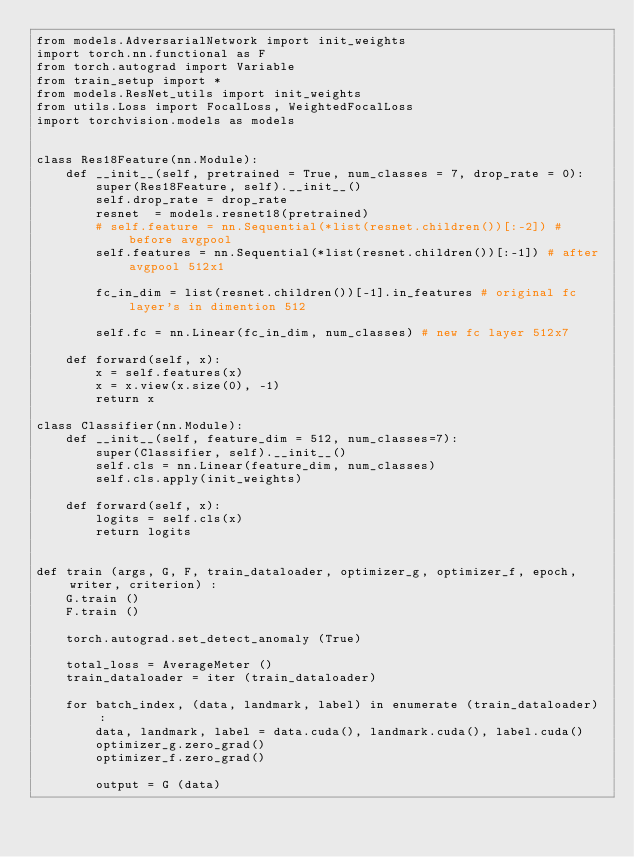Convert code to text. <code><loc_0><loc_0><loc_500><loc_500><_Python_>from models.AdversarialNetwork import init_weights
import torch.nn.functional as F
from torch.autograd import Variable
from train_setup import *
from models.ResNet_utils import init_weights
from utils.Loss import FocalLoss, WeightedFocalLoss
import torchvision.models as models


class Res18Feature(nn.Module):
    def __init__(self, pretrained = True, num_classes = 7, drop_rate = 0):
        super(Res18Feature, self).__init__()
        self.drop_rate = drop_rate
        resnet  = models.resnet18(pretrained)
        # self.feature = nn.Sequential(*list(resnet.children())[:-2]) # before avgpool
        self.features = nn.Sequential(*list(resnet.children())[:-1]) # after avgpool 512x1

        fc_in_dim = list(resnet.children())[-1].in_features # original fc layer's in dimention 512

        self.fc = nn.Linear(fc_in_dim, num_classes) # new fc layer 512x7

    def forward(self, x):
        x = self.features(x)
        x = x.view(x.size(0), -1)
        return x

class Classifier(nn.Module):
    def __init__(self, feature_dim = 512, num_classes=7):
        super(Classifier, self).__init__()
        self.cls = nn.Linear(feature_dim, num_classes)        
        self.cls.apply(init_weights)

    def forward(self, x):
        logits = self.cls(x)
        return logits


def train (args, G, F, train_dataloader, optimizer_g, optimizer_f, epoch, writer, criterion) :
    G.train ()
    F.train ()

    torch.autograd.set_detect_anomaly (True)

    total_loss = AverageMeter ()
    train_dataloader = iter (train_dataloader)

    for batch_index, (data, landmark, label) in enumerate (train_dataloader) :
        data, landmark, label = data.cuda(), landmark.cuda(), label.cuda()
        optimizer_g.zero_grad()
        optimizer_f.zero_grad()
        
        output = G (data)</code> 